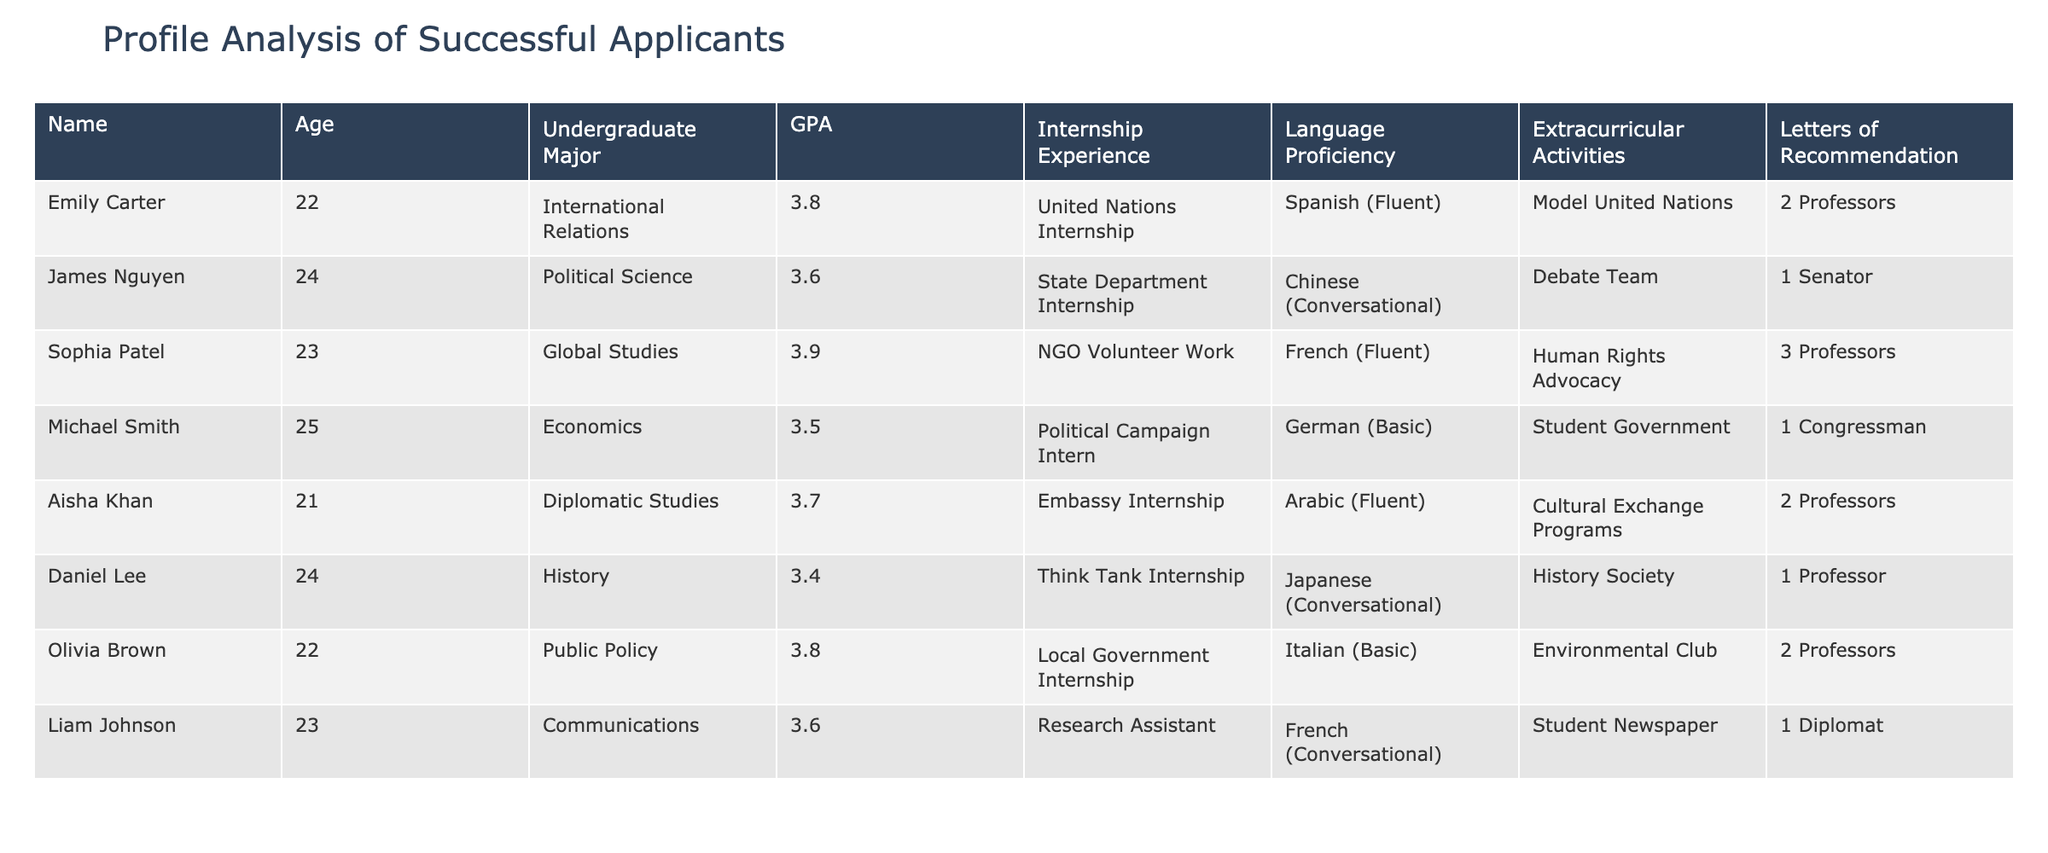What is the highest GPA among the applicants? Looking at the GPA column, Emily Carter has the highest GPA, which is 3.8.
Answer: 3.8 How many applicants have internship experience at the State Department? There is one applicant, James Nguyen, who has an internship experience at the State Department.
Answer: 1 Which language is spoken fluently by the most applicants? The languages of the applicants are Spanish, Chinese, French, German, Arabic, Japanese, and Italian. Spanish and Arabic are each mentioned by one applicant as fluent, while French is fluent for two applicants (Emily Carter and Sophia Patel).
Answer: French What is the average GPA of applicants with at least two letters of recommendation? The applicants with at least two letters of recommendation are Emily Carter (3.8), Sophia Patel (3.9), Aisha Khan (3.7), and Olivia Brown (3.8). Summing their GPAs gives 3.8 + 3.9 + 3.7 + 3.8 = 15.2. Dividing by 4 (the number of applicants) results in an average GPA of 15.2/4 = 3.8.
Answer: 3.8 Is there any applicant with internship experience at both a state and local government? Examining the internship experiences, James Nguyen has a State Department internship, and Olivia Brown has a Local Government internship, but none have both.
Answer: No How many applicants are proficient in a language that is not English? All applicants listed have proficiency in languages other than English (Spanish, Chinese, French, German, Arabic, Japanese, and Italian). Thus, all 8 applicants are proficient in a non-English language.
Answer: 8 Who has the lowest GPA and what is it? Looking at the GPA column, Daniel Lee has the lowest GPA of 3.4 among the applicants.
Answer: 3.4 What is the difference between the highest and lowest GPAs among the applicants? The highest GPA is 3.9 (Sophia Patel) and the lowest is 3.4 (Daniel Lee). The difference is 3.9 - 3.4 = 0.5.
Answer: 0.5 How many applicants have one letter of recommendation? Checking the letters of recommendation, there are three applicants with one letter: James Nguyen, Michael Smith, and Liam Johnson.
Answer: 3 